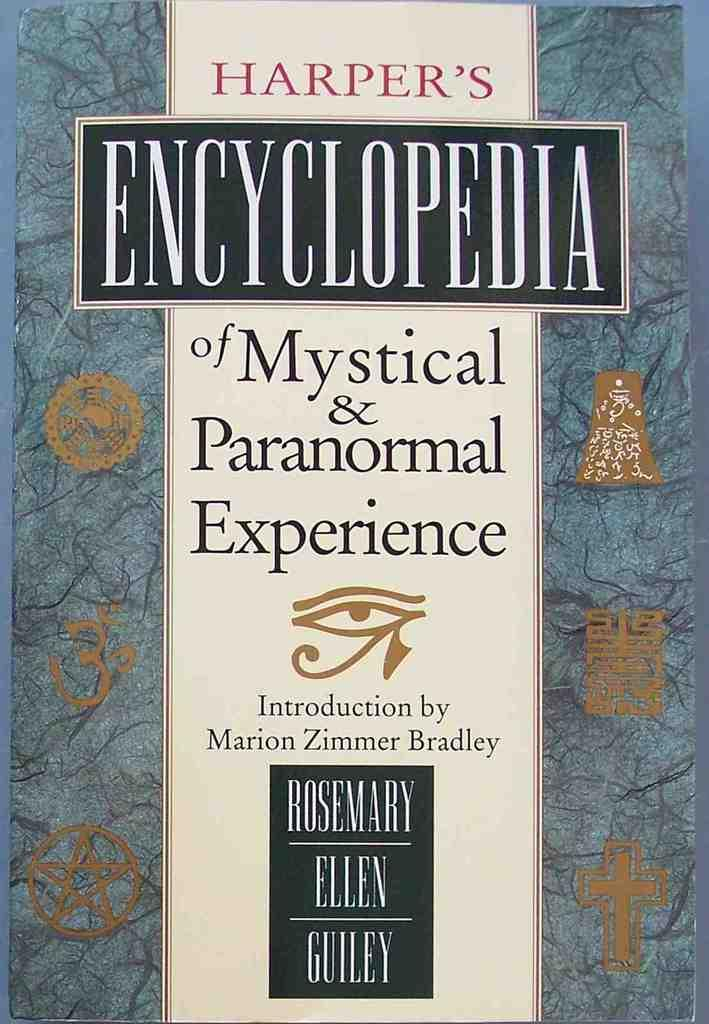What is present in the image that contains visuals and text? There is a poster in the image that contains pictures and text. Can you describe the pictures on the poster? Unfortunately, the specific pictures on the poster cannot be described without more information. What type of information is conveyed through the text on the poster? The content of the text on the poster cannot be determined without more information. What type of vegetable is being traded in the image? There is no vegetable or trade activity depicted in the image; it only features a poster with pictures and text. 